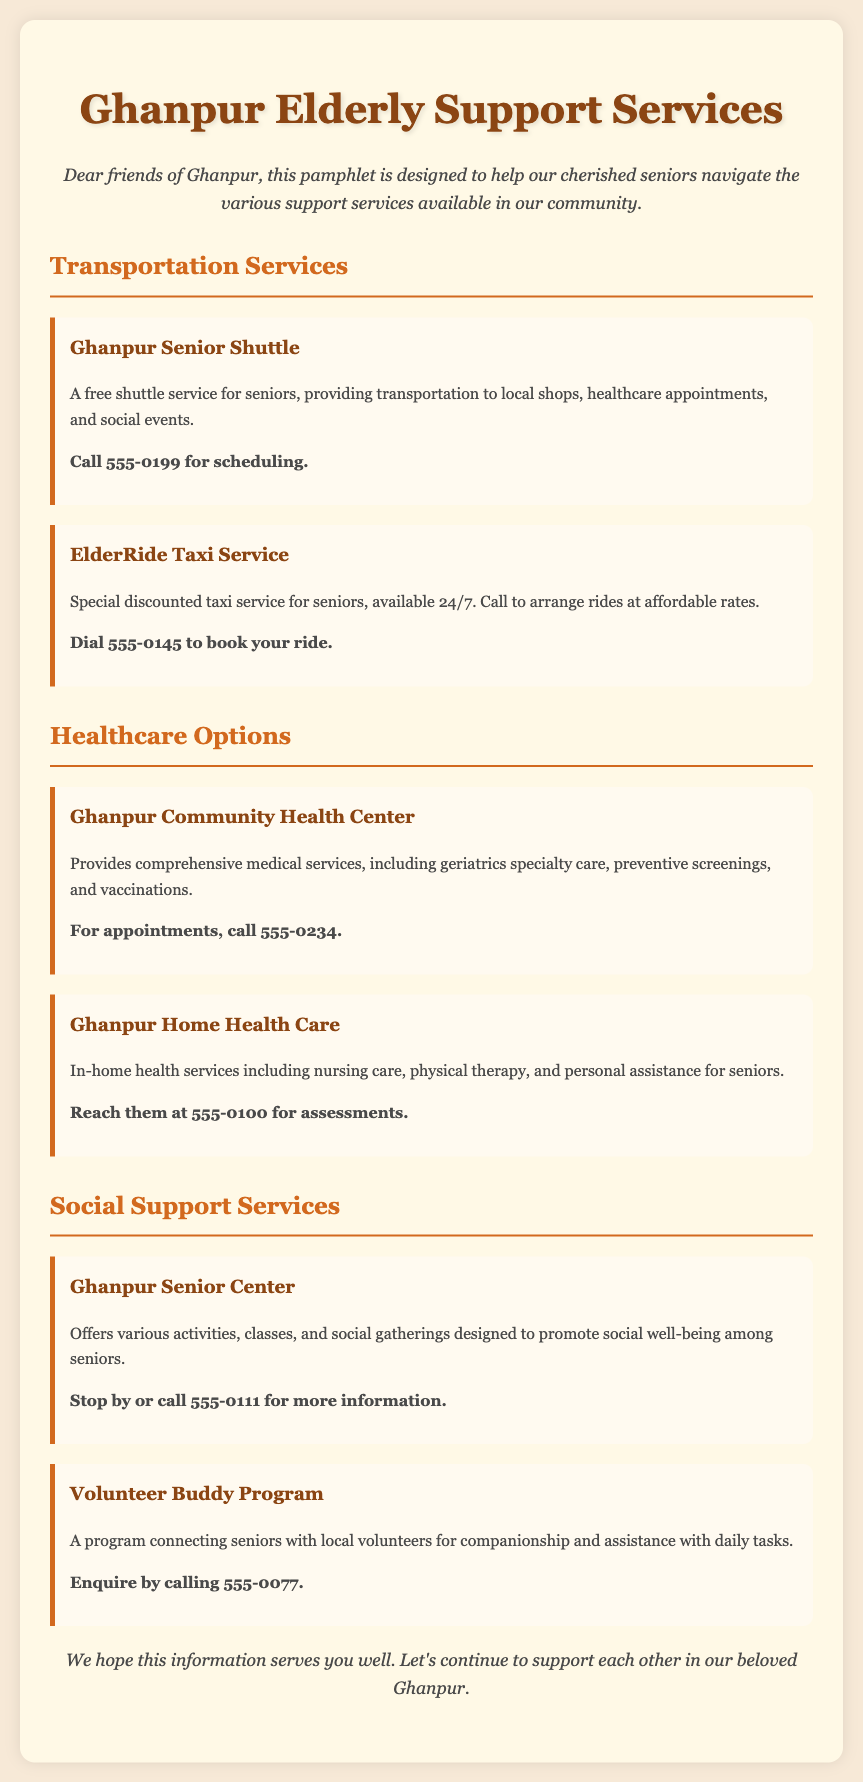What transportation service is free for seniors? The document mentions the "Ghanpur Senior Shuttle" as providing free transportation for seniors.
Answer: Ghanpur Senior Shuttle What is the contact number for arranging rides with ElderRide? The contact number for ElderRide Taxi Service is specifically provided in the document.
Answer: 555-0145 Which healthcare center offers preventive screenings? The "Ghanpur Community Health Center" is noted for providing comprehensive medical services, including preventive screenings.
Answer: Ghanpur Community Health Center How can seniors receive in-home health services? The document states that "Ghanpur Home Health Care" provides in-home health services and offers a contact for assessments.
Answer: 555-0100 What is the main purpose of the Ghanpur Senior Center? The document describes the Ghanpur Senior Center as a place for activities, classes, and social gatherings aimed at promoting social well-being among seniors.
Answer: Social well-being What program connects seniors with local volunteers? The document refers to the "Volunteer Buddy Program" as a service connecting seniors with volunteers for companionship and assistance.
Answer: Volunteer Buddy Program How are the healthcare services structured in the document? The document outlines healthcare options under a specific header, detailing the services and contact information for each.
Answer: By categories What activities does the Ghanpur Senior Center offer? It is mentioned that the Senior Center offers various activities, classes, and social gatherings for seniors.
Answer: Activities, classes, and social gatherings 